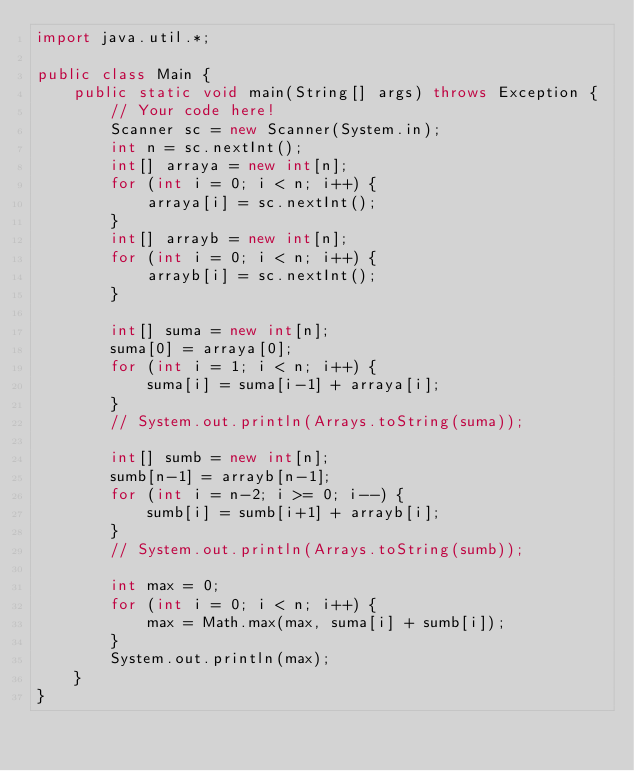<code> <loc_0><loc_0><loc_500><loc_500><_Java_>import java.util.*;

public class Main {
    public static void main(String[] args) throws Exception {
        // Your code here!
        Scanner sc = new Scanner(System.in);
        int n = sc.nextInt();
        int[] arraya = new int[n];
        for (int i = 0; i < n; i++) {
            arraya[i] = sc.nextInt();
        }
        int[] arrayb = new int[n];
        for (int i = 0; i < n; i++) {
            arrayb[i] = sc.nextInt();
        }
        
        int[] suma = new int[n];
        suma[0] = arraya[0];
        for (int i = 1; i < n; i++) {
            suma[i] = suma[i-1] + arraya[i];
        }
        // System.out.println(Arrays.toString(suma));
        
        int[] sumb = new int[n];
        sumb[n-1] = arrayb[n-1];
        for (int i = n-2; i >= 0; i--) {
            sumb[i] = sumb[i+1] + arrayb[i];
        }
        // System.out.println(Arrays.toString(sumb));
        
        int max = 0;
        for (int i = 0; i < n; i++) {
            max = Math.max(max, suma[i] + sumb[i]);
        }
        System.out.println(max);
    }
}
</code> 